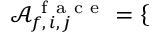Convert formula to latex. <formula><loc_0><loc_0><loc_500><loc_500>\mathcal { A } _ { f , \, i , \, j } ^ { f a c e } = \left \{ \begin{array} { l l } \end{array}</formula> 